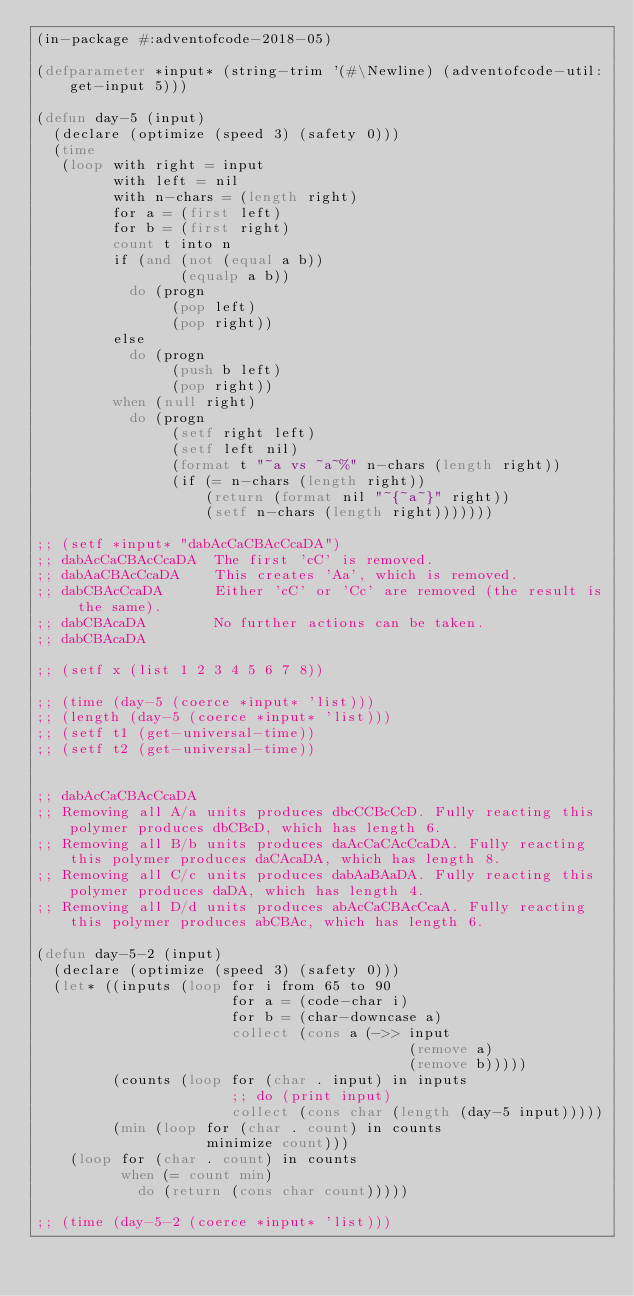<code> <loc_0><loc_0><loc_500><loc_500><_Lisp_>(in-package #:adventofcode-2018-05)

(defparameter *input* (string-trim '(#\Newline) (adventofcode-util:get-input 5)))

(defun day-5 (input)
  (declare (optimize (speed 3) (safety 0)))
  (time
   (loop with right = input
         with left = nil
         with n-chars = (length right)
         for a = (first left)
         for b = (first right)
         count t into n
         if (and (not (equal a b))
                 (equalp a b))
           do (progn
                (pop left)
                (pop right))
         else
           do (progn
                (push b left)
                (pop right))
         when (null right)
           do (progn
                (setf right left)
                (setf left nil)
                (format t "~a vs ~a~%" n-chars (length right))
                (if (= n-chars (length right))
                    (return (format nil "~{~a~}" right))
                    (setf n-chars (length right)))))))

;; (setf *input* "dabAcCaCBAcCcaDA")
;; dabAcCaCBAcCcaDA  The first 'cC' is removed.
;; dabAaCBAcCcaDA    This creates 'Aa', which is removed.
;; dabCBAcCcaDA      Either 'cC' or 'Cc' are removed (the result is the same).
;; dabCBAcaDA        No further actions can be taken.
;; dabCBAcaDA

;; (setf x (list 1 2 3 4 5 6 7 8))

;; (time (day-5 (coerce *input* 'list)))
;; (length (day-5 (coerce *input* 'list)))
;; (setf t1 (get-universal-time))
;; (setf t2 (get-universal-time))


;; dabAcCaCBAcCcaDA
;; Removing all A/a units produces dbcCCBcCcD. Fully reacting this polymer produces dbCBcD, which has length 6.
;; Removing all B/b units produces daAcCaCAcCcaDA. Fully reacting this polymer produces daCAcaDA, which has length 8.
;; Removing all C/c units produces dabAaBAaDA. Fully reacting this polymer produces daDA, which has length 4.
;; Removing all D/d units produces abAcCaCBAcCcaA. Fully reacting this polymer produces abCBAc, which has length 6.

(defun day-5-2 (input)
  (declare (optimize (speed 3) (safety 0)))
  (let* ((inputs (loop for i from 65 to 90
                       for a = (code-char i)
                       for b = (char-downcase a)
                       collect (cons a (->> input
                                            (remove a)
                                            (remove b)))))
         (counts (loop for (char . input) in inputs
                       ;; do (print input)
                       collect (cons char (length (day-5 input)))))
         (min (loop for (char . count) in counts
                    minimize count)))
    (loop for (char . count) in counts
          when (= count min)
            do (return (cons char count)))))

;; (time (day-5-2 (coerce *input* 'list)))
</code> 